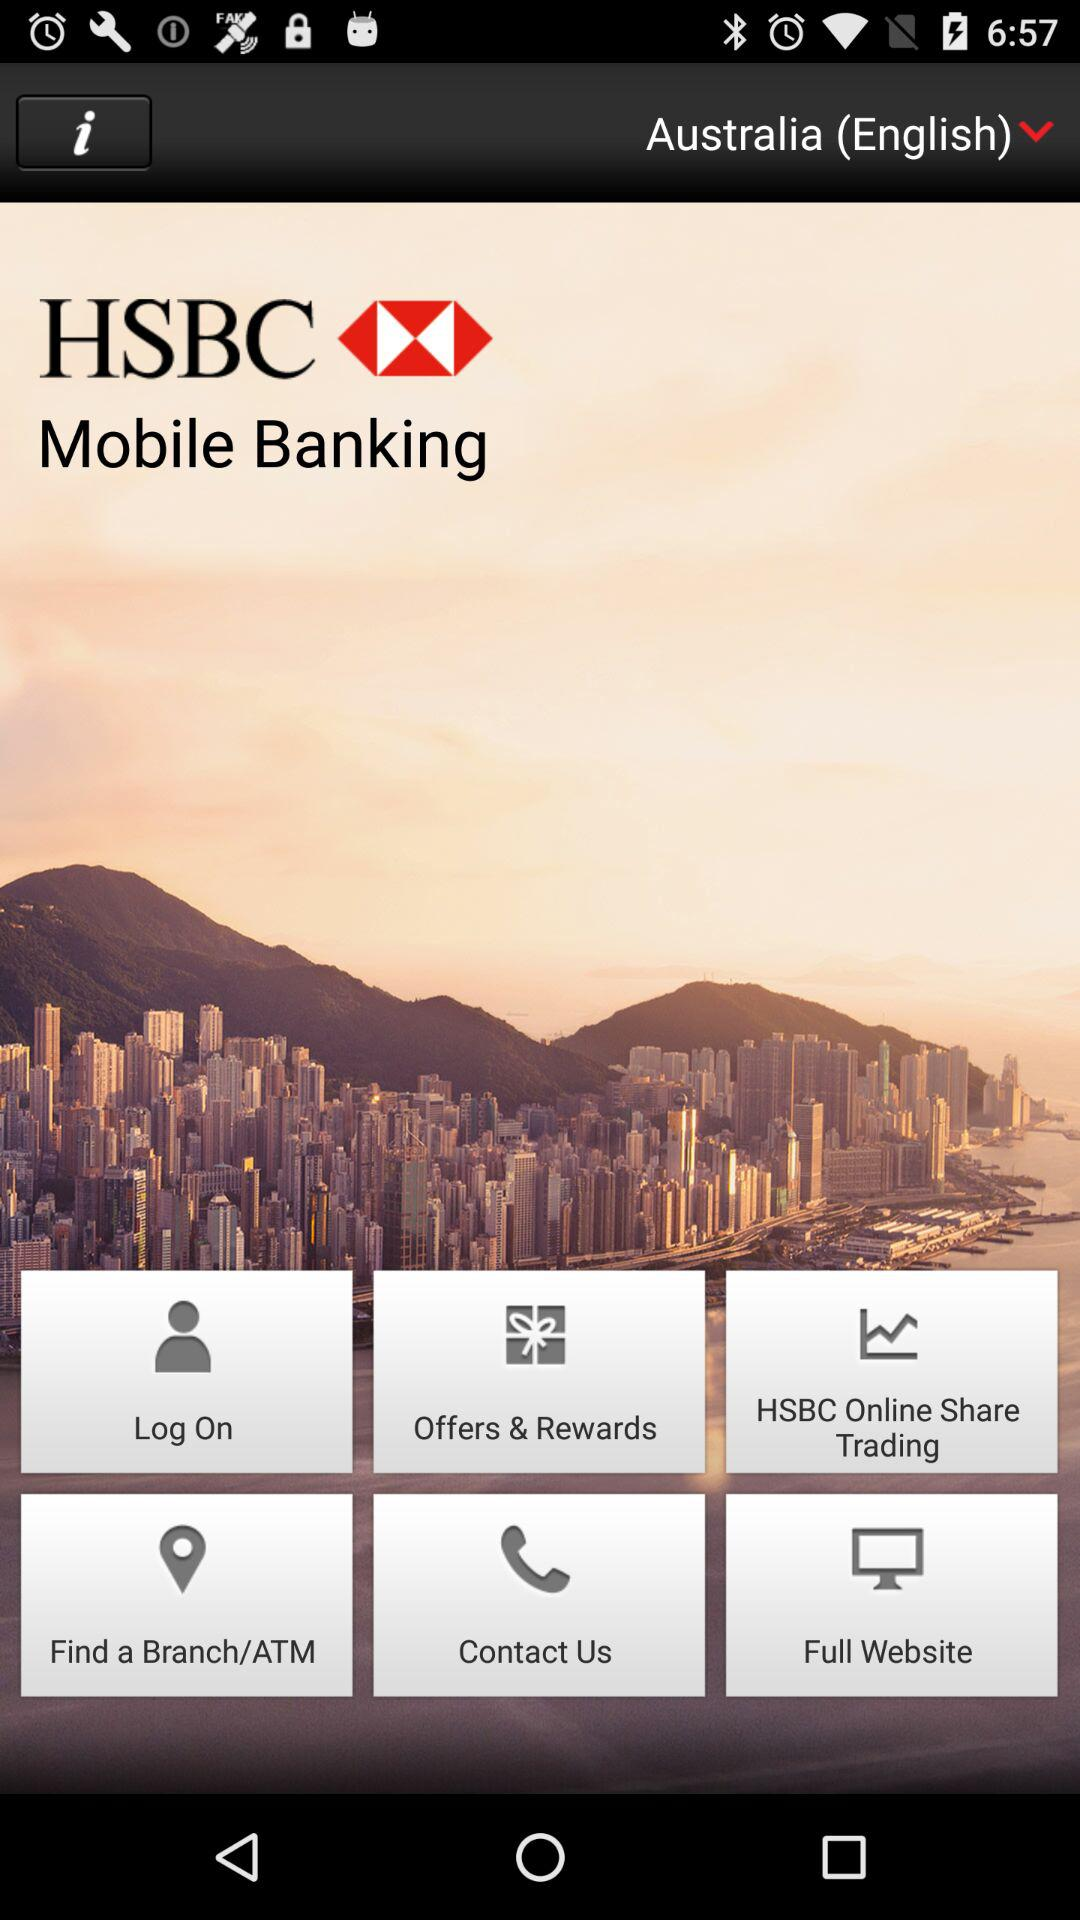What is the name of the application? The name of the application is "HSBC Mobile Banking". 